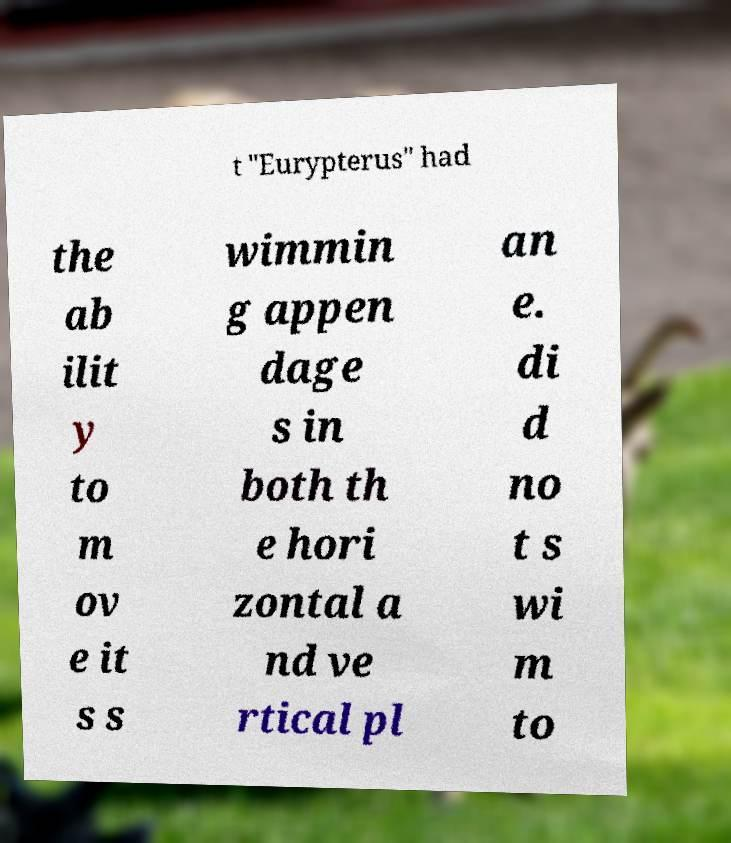I need the written content from this picture converted into text. Can you do that? t "Eurypterus" had the ab ilit y to m ov e it s s wimmin g appen dage s in both th e hori zontal a nd ve rtical pl an e. di d no t s wi m to 